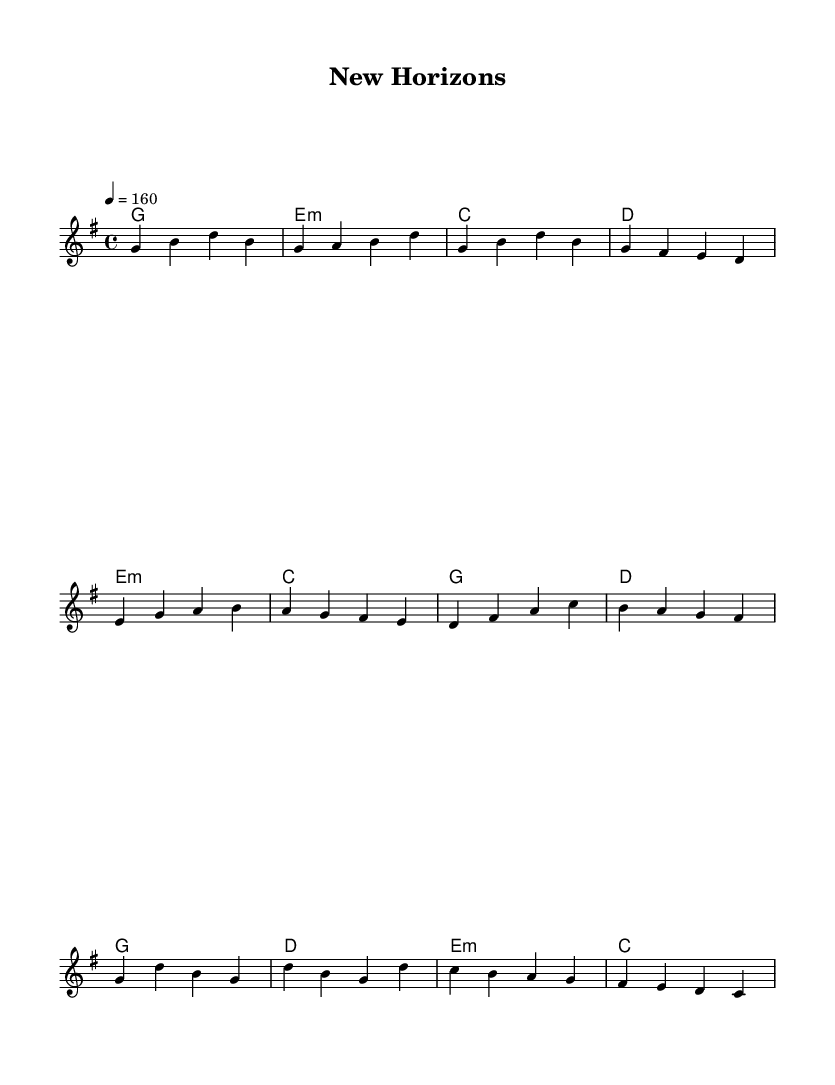What is the key signature of this music? The key signature is G major, which has one sharp (F#). This is indicated in the global section at the beginning of the music notation with the command "\key g \major".
Answer: G major What is the time signature of the piece? The time signature is 4/4, indicating that there are four beats per measure and the quarter note receives one beat. This is shown in the global section with the command "\time 4/4".
Answer: 4/4 What is the tempo marking for this song? The tempo marking is 160 beats per minute, which is indicated in the global section with the command "\tempo 4 = 160". This gives the performer a guideline on how fast the piece should be played.
Answer: 160 How many measures does the chorus section contain? The chorus section contains four measures. There are four distinct measure markings in the melody corresponding to the chorus lyrics provided.
Answer: 4 What is the lyrical theme represented in the song? The lyrical theme revolves around exploring new experiences and independence in college life, as inferred from phrases like "New faces, new places" and "learning to stand on my own." This reflects the general feelings of excitement and challenges faced by students.
Answer: Independence What harmonic progression is used in the verse? The harmonic progression for the verse is G - E minor - C - D. This means that the chords played alongside the melody during the verse are arranged in this sequence, providing context and support for the melody.
Answer: G - E minor - C - D What type of lyrical writing style is evident in the pre-chorus? The lyrical writing style is characterized by a narrative approach, expressing personal growth and self-discovery in the context of college life. This type of storytelling is common in punk music, which often conveys emotional experiences.
Answer: Narrative 